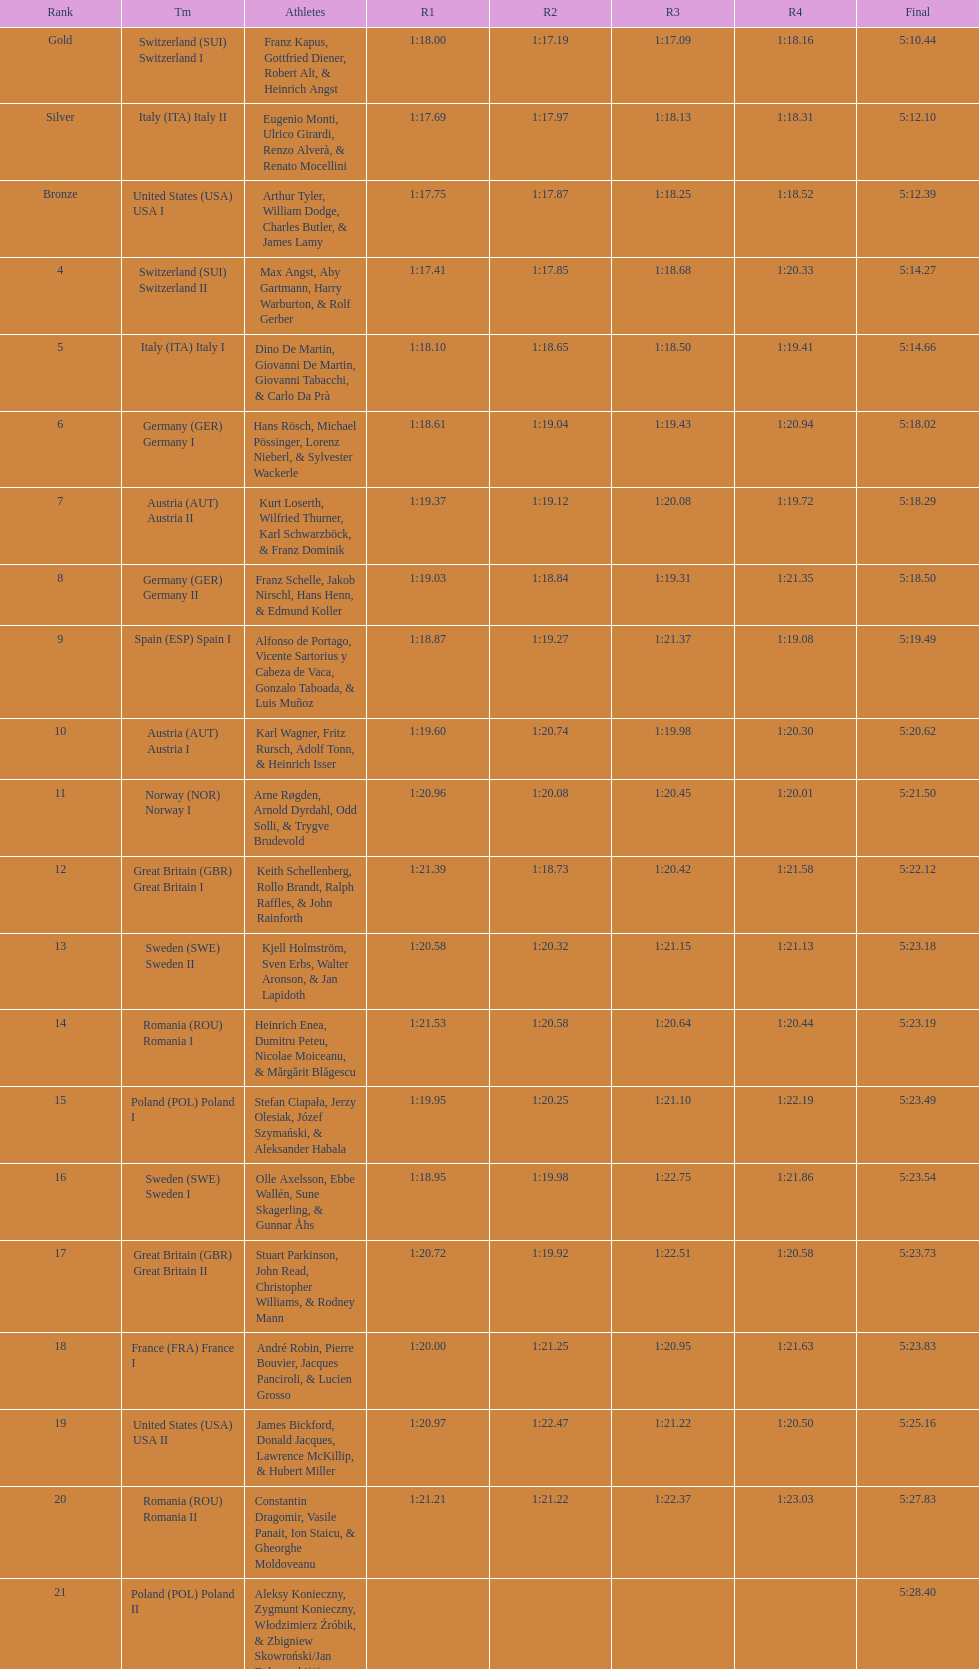How many teams did germany have? 2. 